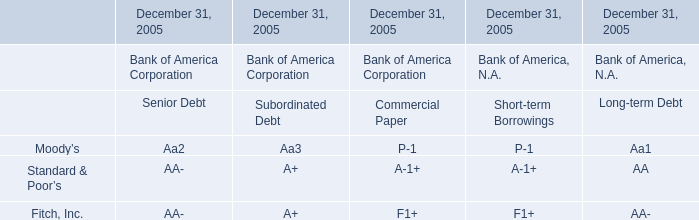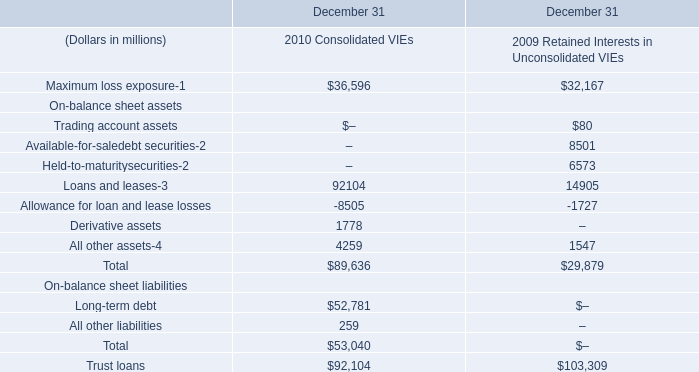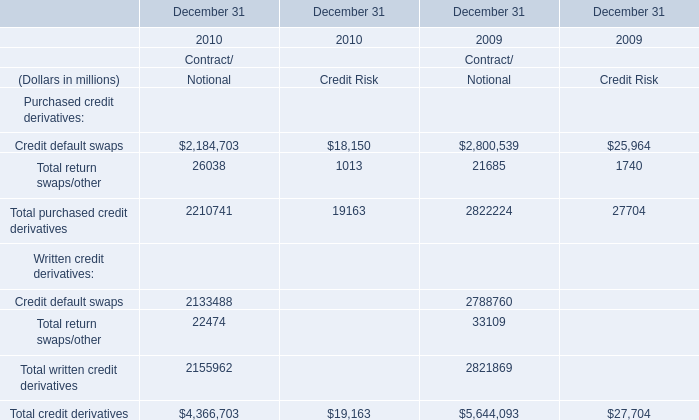what was the ratio of the fair value of the preliminary debt analysis of the acquisition date fair value of the borrowings for 2014 to 2013 
Computations: (2.16 / 2.49)
Answer: 0.86747. 